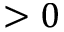<formula> <loc_0><loc_0><loc_500><loc_500>> 0</formula> 